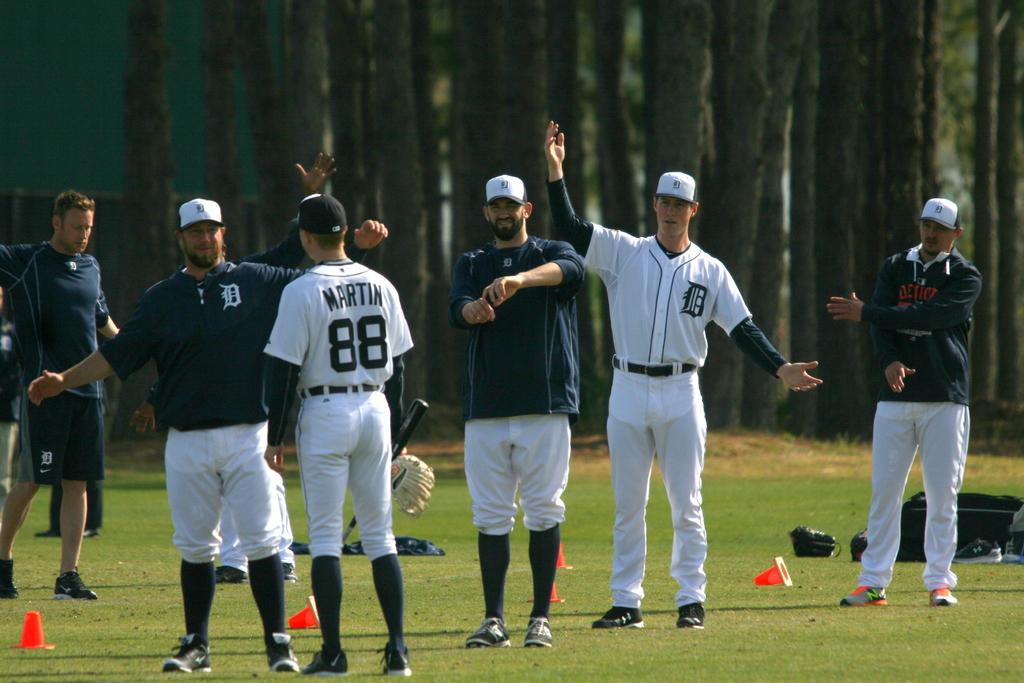<image>
Summarize the visual content of the image. The player with the Martin jersey number 88 is talking with other players at training event. 